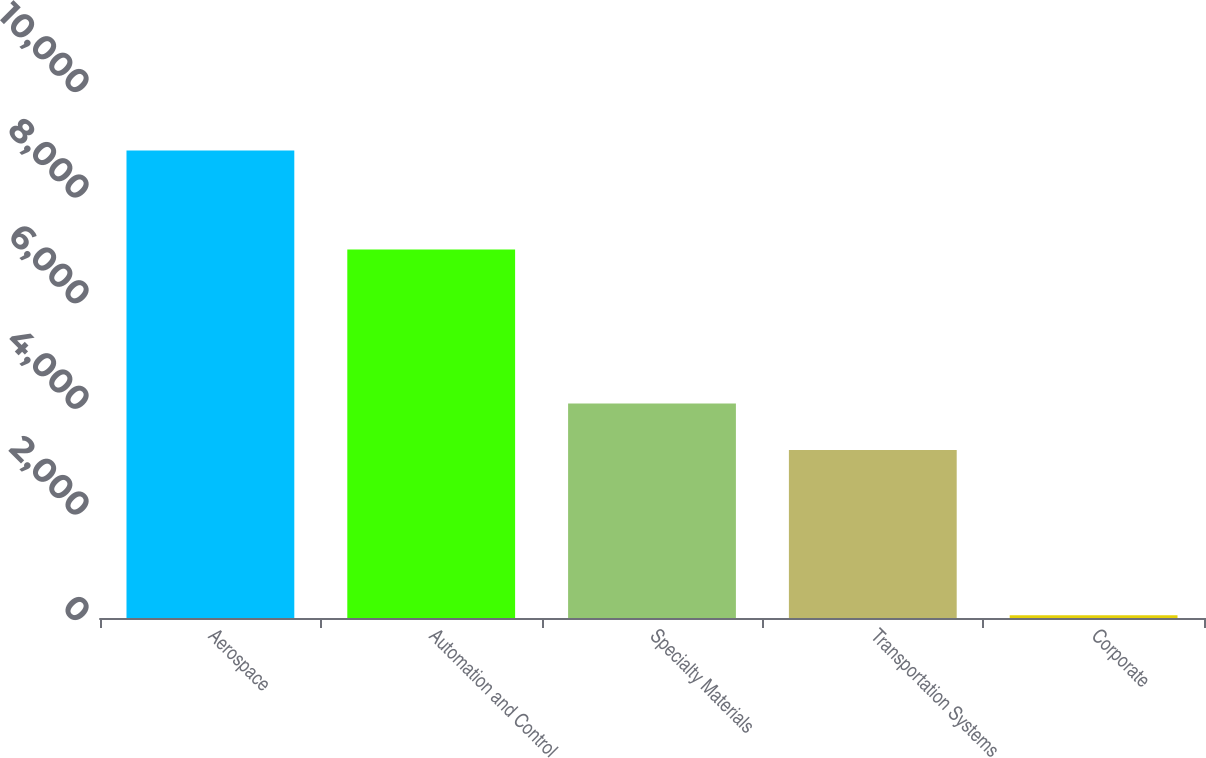Convert chart to OTSL. <chart><loc_0><loc_0><loc_500><loc_500><bar_chart><fcel>Aerospace<fcel>Automation and Control<fcel>Specialty Materials<fcel>Transportation Systems<fcel>Corporate<nl><fcel>8855<fcel>6978<fcel>4064.3<fcel>3184<fcel>52<nl></chart> 